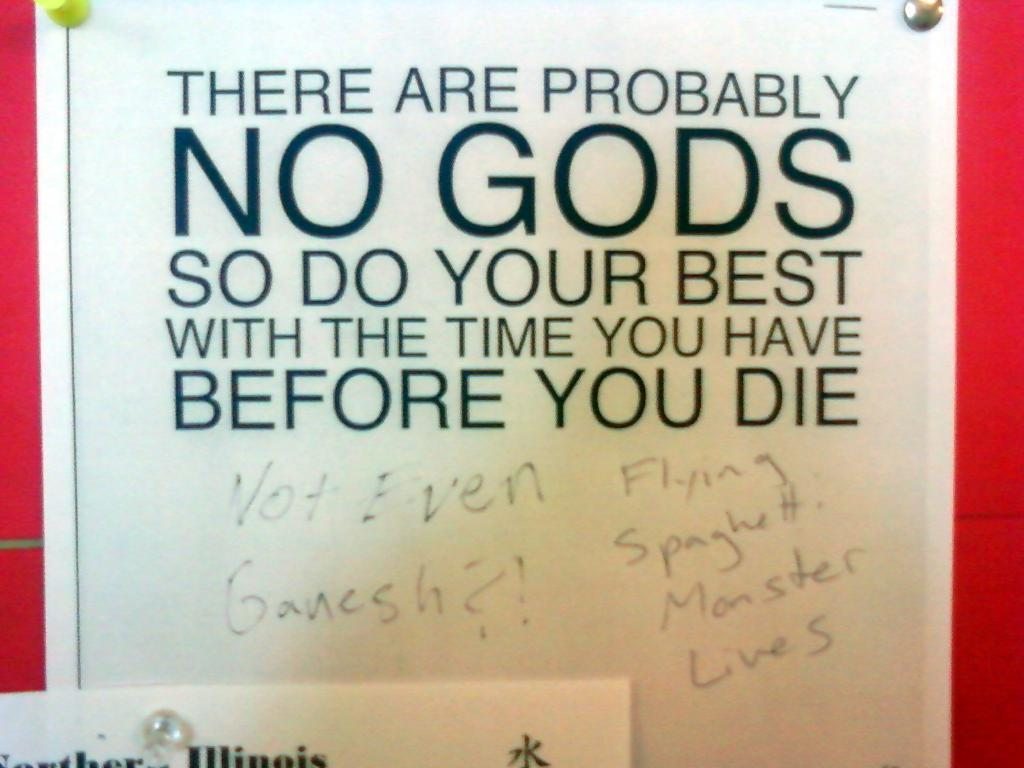<image>
Write a terse but informative summary of the picture. A sign that suggests that we should all live our lives to the fullest as there probably is no God and so no afterlife. 